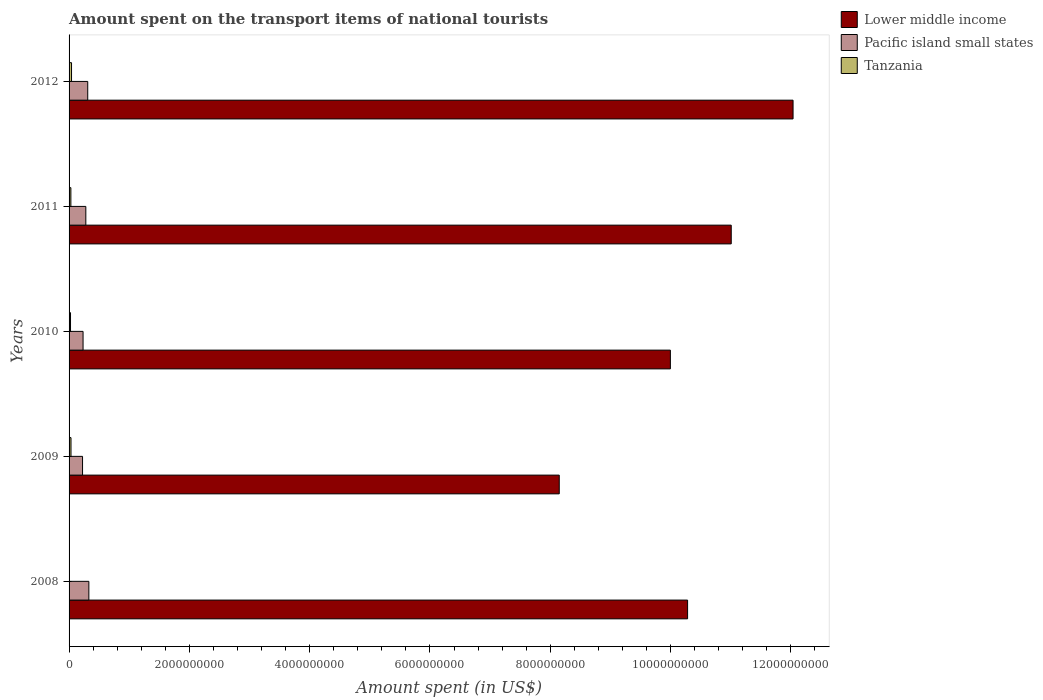How many different coloured bars are there?
Offer a terse response. 3. Are the number of bars per tick equal to the number of legend labels?
Your response must be concise. Yes. Are the number of bars on each tick of the Y-axis equal?
Provide a short and direct response. Yes. What is the amount spent on the transport items of national tourists in Tanzania in 2010?
Ensure brevity in your answer.  2.40e+07. Across all years, what is the maximum amount spent on the transport items of national tourists in Lower middle income?
Offer a very short reply. 1.20e+1. Across all years, what is the minimum amount spent on the transport items of national tourists in Pacific island small states?
Offer a very short reply. 2.24e+08. What is the total amount spent on the transport items of national tourists in Pacific island small states in the graph?
Offer a terse response. 1.37e+09. What is the difference between the amount spent on the transport items of national tourists in Pacific island small states in 2010 and that in 2012?
Provide a short and direct response. -7.77e+07. What is the difference between the amount spent on the transport items of national tourists in Tanzania in 2008 and the amount spent on the transport items of national tourists in Lower middle income in 2012?
Ensure brevity in your answer.  -1.20e+1. What is the average amount spent on the transport items of national tourists in Tanzania per year?
Keep it short and to the point. 2.62e+07. In the year 2012, what is the difference between the amount spent on the transport items of national tourists in Pacific island small states and amount spent on the transport items of national tourists in Lower middle income?
Offer a terse response. -1.17e+1. In how many years, is the amount spent on the transport items of national tourists in Pacific island small states greater than 11200000000 US$?
Your answer should be very brief. 0. What is the ratio of the amount spent on the transport items of national tourists in Tanzania in 2010 to that in 2011?
Provide a succinct answer. 0.8. Is the difference between the amount spent on the transport items of national tourists in Pacific island small states in 2008 and 2012 greater than the difference between the amount spent on the transport items of national tourists in Lower middle income in 2008 and 2012?
Provide a short and direct response. Yes. What is the difference between the highest and the second highest amount spent on the transport items of national tourists in Pacific island small states?
Make the answer very short. 1.85e+07. What is the difference between the highest and the lowest amount spent on the transport items of national tourists in Lower middle income?
Your answer should be very brief. 3.89e+09. Is the sum of the amount spent on the transport items of national tourists in Tanzania in 2010 and 2011 greater than the maximum amount spent on the transport items of national tourists in Lower middle income across all years?
Your answer should be compact. No. What does the 1st bar from the top in 2012 represents?
Offer a terse response. Tanzania. What does the 2nd bar from the bottom in 2011 represents?
Offer a terse response. Pacific island small states. Is it the case that in every year, the sum of the amount spent on the transport items of national tourists in Tanzania and amount spent on the transport items of national tourists in Pacific island small states is greater than the amount spent on the transport items of national tourists in Lower middle income?
Offer a very short reply. No. How many bars are there?
Give a very brief answer. 15. What is the difference between two consecutive major ticks on the X-axis?
Your answer should be compact. 2.00e+09. Are the values on the major ticks of X-axis written in scientific E-notation?
Provide a short and direct response. No. Does the graph contain any zero values?
Make the answer very short. No. What is the title of the graph?
Give a very brief answer. Amount spent on the transport items of national tourists. What is the label or title of the X-axis?
Make the answer very short. Amount spent (in US$). What is the Amount spent (in US$) of Lower middle income in 2008?
Your response must be concise. 1.03e+1. What is the Amount spent (in US$) of Pacific island small states in 2008?
Provide a succinct answer. 3.29e+08. What is the Amount spent (in US$) of Tanzania in 2008?
Your answer should be very brief. 4.00e+06. What is the Amount spent (in US$) in Lower middle income in 2009?
Offer a terse response. 8.15e+09. What is the Amount spent (in US$) of Pacific island small states in 2009?
Offer a very short reply. 2.24e+08. What is the Amount spent (in US$) of Tanzania in 2009?
Offer a terse response. 3.20e+07. What is the Amount spent (in US$) of Lower middle income in 2010?
Keep it short and to the point. 1.00e+1. What is the Amount spent (in US$) in Pacific island small states in 2010?
Your answer should be compact. 2.33e+08. What is the Amount spent (in US$) of Tanzania in 2010?
Make the answer very short. 2.40e+07. What is the Amount spent (in US$) in Lower middle income in 2011?
Your answer should be compact. 1.10e+1. What is the Amount spent (in US$) in Pacific island small states in 2011?
Provide a short and direct response. 2.79e+08. What is the Amount spent (in US$) in Tanzania in 2011?
Offer a very short reply. 3.00e+07. What is the Amount spent (in US$) of Lower middle income in 2012?
Give a very brief answer. 1.20e+1. What is the Amount spent (in US$) in Pacific island small states in 2012?
Give a very brief answer. 3.10e+08. What is the Amount spent (in US$) in Tanzania in 2012?
Provide a short and direct response. 4.10e+07. Across all years, what is the maximum Amount spent (in US$) of Lower middle income?
Offer a very short reply. 1.20e+1. Across all years, what is the maximum Amount spent (in US$) of Pacific island small states?
Your response must be concise. 3.29e+08. Across all years, what is the maximum Amount spent (in US$) of Tanzania?
Give a very brief answer. 4.10e+07. Across all years, what is the minimum Amount spent (in US$) in Lower middle income?
Ensure brevity in your answer.  8.15e+09. Across all years, what is the minimum Amount spent (in US$) in Pacific island small states?
Your response must be concise. 2.24e+08. Across all years, what is the minimum Amount spent (in US$) in Tanzania?
Your response must be concise. 4.00e+06. What is the total Amount spent (in US$) of Lower middle income in the graph?
Your response must be concise. 5.15e+1. What is the total Amount spent (in US$) in Pacific island small states in the graph?
Your answer should be compact. 1.37e+09. What is the total Amount spent (in US$) in Tanzania in the graph?
Ensure brevity in your answer.  1.31e+08. What is the difference between the Amount spent (in US$) in Lower middle income in 2008 and that in 2009?
Your answer should be very brief. 2.13e+09. What is the difference between the Amount spent (in US$) of Pacific island small states in 2008 and that in 2009?
Ensure brevity in your answer.  1.05e+08. What is the difference between the Amount spent (in US$) of Tanzania in 2008 and that in 2009?
Give a very brief answer. -2.80e+07. What is the difference between the Amount spent (in US$) of Lower middle income in 2008 and that in 2010?
Provide a short and direct response. 2.86e+08. What is the difference between the Amount spent (in US$) of Pacific island small states in 2008 and that in 2010?
Provide a succinct answer. 9.62e+07. What is the difference between the Amount spent (in US$) of Tanzania in 2008 and that in 2010?
Ensure brevity in your answer.  -2.00e+07. What is the difference between the Amount spent (in US$) in Lower middle income in 2008 and that in 2011?
Offer a terse response. -7.26e+08. What is the difference between the Amount spent (in US$) in Pacific island small states in 2008 and that in 2011?
Offer a very short reply. 5.02e+07. What is the difference between the Amount spent (in US$) in Tanzania in 2008 and that in 2011?
Your answer should be compact. -2.60e+07. What is the difference between the Amount spent (in US$) of Lower middle income in 2008 and that in 2012?
Your answer should be compact. -1.75e+09. What is the difference between the Amount spent (in US$) of Pacific island small states in 2008 and that in 2012?
Offer a terse response. 1.85e+07. What is the difference between the Amount spent (in US$) of Tanzania in 2008 and that in 2012?
Provide a succinct answer. -3.70e+07. What is the difference between the Amount spent (in US$) of Lower middle income in 2009 and that in 2010?
Your response must be concise. -1.85e+09. What is the difference between the Amount spent (in US$) in Pacific island small states in 2009 and that in 2010?
Provide a succinct answer. -8.73e+06. What is the difference between the Amount spent (in US$) in Lower middle income in 2009 and that in 2011?
Provide a succinct answer. -2.86e+09. What is the difference between the Amount spent (in US$) in Pacific island small states in 2009 and that in 2011?
Ensure brevity in your answer.  -5.47e+07. What is the difference between the Amount spent (in US$) of Tanzania in 2009 and that in 2011?
Make the answer very short. 2.00e+06. What is the difference between the Amount spent (in US$) of Lower middle income in 2009 and that in 2012?
Provide a succinct answer. -3.89e+09. What is the difference between the Amount spent (in US$) of Pacific island small states in 2009 and that in 2012?
Offer a terse response. -8.64e+07. What is the difference between the Amount spent (in US$) in Tanzania in 2009 and that in 2012?
Give a very brief answer. -9.00e+06. What is the difference between the Amount spent (in US$) in Lower middle income in 2010 and that in 2011?
Your answer should be very brief. -1.01e+09. What is the difference between the Amount spent (in US$) in Pacific island small states in 2010 and that in 2011?
Your answer should be very brief. -4.60e+07. What is the difference between the Amount spent (in US$) of Tanzania in 2010 and that in 2011?
Your answer should be very brief. -6.00e+06. What is the difference between the Amount spent (in US$) in Lower middle income in 2010 and that in 2012?
Make the answer very short. -2.04e+09. What is the difference between the Amount spent (in US$) in Pacific island small states in 2010 and that in 2012?
Offer a terse response. -7.77e+07. What is the difference between the Amount spent (in US$) of Tanzania in 2010 and that in 2012?
Ensure brevity in your answer.  -1.70e+07. What is the difference between the Amount spent (in US$) of Lower middle income in 2011 and that in 2012?
Your response must be concise. -1.03e+09. What is the difference between the Amount spent (in US$) in Pacific island small states in 2011 and that in 2012?
Make the answer very short. -3.17e+07. What is the difference between the Amount spent (in US$) in Tanzania in 2011 and that in 2012?
Keep it short and to the point. -1.10e+07. What is the difference between the Amount spent (in US$) of Lower middle income in 2008 and the Amount spent (in US$) of Pacific island small states in 2009?
Keep it short and to the point. 1.01e+1. What is the difference between the Amount spent (in US$) of Lower middle income in 2008 and the Amount spent (in US$) of Tanzania in 2009?
Your answer should be compact. 1.03e+1. What is the difference between the Amount spent (in US$) of Pacific island small states in 2008 and the Amount spent (in US$) of Tanzania in 2009?
Provide a succinct answer. 2.97e+08. What is the difference between the Amount spent (in US$) of Lower middle income in 2008 and the Amount spent (in US$) of Pacific island small states in 2010?
Give a very brief answer. 1.00e+1. What is the difference between the Amount spent (in US$) in Lower middle income in 2008 and the Amount spent (in US$) in Tanzania in 2010?
Offer a terse response. 1.03e+1. What is the difference between the Amount spent (in US$) of Pacific island small states in 2008 and the Amount spent (in US$) of Tanzania in 2010?
Make the answer very short. 3.05e+08. What is the difference between the Amount spent (in US$) of Lower middle income in 2008 and the Amount spent (in US$) of Pacific island small states in 2011?
Make the answer very short. 1.00e+1. What is the difference between the Amount spent (in US$) of Lower middle income in 2008 and the Amount spent (in US$) of Tanzania in 2011?
Keep it short and to the point. 1.03e+1. What is the difference between the Amount spent (in US$) in Pacific island small states in 2008 and the Amount spent (in US$) in Tanzania in 2011?
Offer a very short reply. 2.99e+08. What is the difference between the Amount spent (in US$) in Lower middle income in 2008 and the Amount spent (in US$) in Pacific island small states in 2012?
Your response must be concise. 9.97e+09. What is the difference between the Amount spent (in US$) of Lower middle income in 2008 and the Amount spent (in US$) of Tanzania in 2012?
Provide a short and direct response. 1.02e+1. What is the difference between the Amount spent (in US$) of Pacific island small states in 2008 and the Amount spent (in US$) of Tanzania in 2012?
Give a very brief answer. 2.88e+08. What is the difference between the Amount spent (in US$) of Lower middle income in 2009 and the Amount spent (in US$) of Pacific island small states in 2010?
Keep it short and to the point. 7.92e+09. What is the difference between the Amount spent (in US$) in Lower middle income in 2009 and the Amount spent (in US$) in Tanzania in 2010?
Provide a succinct answer. 8.12e+09. What is the difference between the Amount spent (in US$) in Pacific island small states in 2009 and the Amount spent (in US$) in Tanzania in 2010?
Make the answer very short. 2.00e+08. What is the difference between the Amount spent (in US$) of Lower middle income in 2009 and the Amount spent (in US$) of Pacific island small states in 2011?
Provide a succinct answer. 7.87e+09. What is the difference between the Amount spent (in US$) in Lower middle income in 2009 and the Amount spent (in US$) in Tanzania in 2011?
Keep it short and to the point. 8.12e+09. What is the difference between the Amount spent (in US$) in Pacific island small states in 2009 and the Amount spent (in US$) in Tanzania in 2011?
Offer a very short reply. 1.94e+08. What is the difference between the Amount spent (in US$) in Lower middle income in 2009 and the Amount spent (in US$) in Pacific island small states in 2012?
Make the answer very short. 7.84e+09. What is the difference between the Amount spent (in US$) of Lower middle income in 2009 and the Amount spent (in US$) of Tanzania in 2012?
Offer a terse response. 8.11e+09. What is the difference between the Amount spent (in US$) of Pacific island small states in 2009 and the Amount spent (in US$) of Tanzania in 2012?
Make the answer very short. 1.83e+08. What is the difference between the Amount spent (in US$) in Lower middle income in 2010 and the Amount spent (in US$) in Pacific island small states in 2011?
Ensure brevity in your answer.  9.72e+09. What is the difference between the Amount spent (in US$) in Lower middle income in 2010 and the Amount spent (in US$) in Tanzania in 2011?
Your answer should be compact. 9.97e+09. What is the difference between the Amount spent (in US$) of Pacific island small states in 2010 and the Amount spent (in US$) of Tanzania in 2011?
Your answer should be very brief. 2.03e+08. What is the difference between the Amount spent (in US$) of Lower middle income in 2010 and the Amount spent (in US$) of Pacific island small states in 2012?
Give a very brief answer. 9.69e+09. What is the difference between the Amount spent (in US$) in Lower middle income in 2010 and the Amount spent (in US$) in Tanzania in 2012?
Make the answer very short. 9.96e+09. What is the difference between the Amount spent (in US$) of Pacific island small states in 2010 and the Amount spent (in US$) of Tanzania in 2012?
Offer a terse response. 1.92e+08. What is the difference between the Amount spent (in US$) in Lower middle income in 2011 and the Amount spent (in US$) in Pacific island small states in 2012?
Keep it short and to the point. 1.07e+1. What is the difference between the Amount spent (in US$) of Lower middle income in 2011 and the Amount spent (in US$) of Tanzania in 2012?
Your answer should be compact. 1.10e+1. What is the difference between the Amount spent (in US$) of Pacific island small states in 2011 and the Amount spent (in US$) of Tanzania in 2012?
Your answer should be very brief. 2.38e+08. What is the average Amount spent (in US$) of Lower middle income per year?
Give a very brief answer. 1.03e+1. What is the average Amount spent (in US$) of Pacific island small states per year?
Ensure brevity in your answer.  2.75e+08. What is the average Amount spent (in US$) of Tanzania per year?
Offer a very short reply. 2.62e+07. In the year 2008, what is the difference between the Amount spent (in US$) of Lower middle income and Amount spent (in US$) of Pacific island small states?
Your answer should be compact. 9.95e+09. In the year 2008, what is the difference between the Amount spent (in US$) of Lower middle income and Amount spent (in US$) of Tanzania?
Offer a very short reply. 1.03e+1. In the year 2008, what is the difference between the Amount spent (in US$) in Pacific island small states and Amount spent (in US$) in Tanzania?
Your response must be concise. 3.25e+08. In the year 2009, what is the difference between the Amount spent (in US$) in Lower middle income and Amount spent (in US$) in Pacific island small states?
Offer a terse response. 7.92e+09. In the year 2009, what is the difference between the Amount spent (in US$) of Lower middle income and Amount spent (in US$) of Tanzania?
Your answer should be very brief. 8.12e+09. In the year 2009, what is the difference between the Amount spent (in US$) in Pacific island small states and Amount spent (in US$) in Tanzania?
Keep it short and to the point. 1.92e+08. In the year 2010, what is the difference between the Amount spent (in US$) of Lower middle income and Amount spent (in US$) of Pacific island small states?
Your answer should be compact. 9.76e+09. In the year 2010, what is the difference between the Amount spent (in US$) in Lower middle income and Amount spent (in US$) in Tanzania?
Make the answer very short. 9.97e+09. In the year 2010, what is the difference between the Amount spent (in US$) of Pacific island small states and Amount spent (in US$) of Tanzania?
Provide a succinct answer. 2.09e+08. In the year 2011, what is the difference between the Amount spent (in US$) of Lower middle income and Amount spent (in US$) of Pacific island small states?
Provide a short and direct response. 1.07e+1. In the year 2011, what is the difference between the Amount spent (in US$) in Lower middle income and Amount spent (in US$) in Tanzania?
Your answer should be compact. 1.10e+1. In the year 2011, what is the difference between the Amount spent (in US$) in Pacific island small states and Amount spent (in US$) in Tanzania?
Your answer should be compact. 2.49e+08. In the year 2012, what is the difference between the Amount spent (in US$) of Lower middle income and Amount spent (in US$) of Pacific island small states?
Give a very brief answer. 1.17e+1. In the year 2012, what is the difference between the Amount spent (in US$) of Lower middle income and Amount spent (in US$) of Tanzania?
Ensure brevity in your answer.  1.20e+1. In the year 2012, what is the difference between the Amount spent (in US$) in Pacific island small states and Amount spent (in US$) in Tanzania?
Offer a very short reply. 2.69e+08. What is the ratio of the Amount spent (in US$) in Lower middle income in 2008 to that in 2009?
Make the answer very short. 1.26. What is the ratio of the Amount spent (in US$) of Pacific island small states in 2008 to that in 2009?
Keep it short and to the point. 1.47. What is the ratio of the Amount spent (in US$) of Tanzania in 2008 to that in 2009?
Your response must be concise. 0.12. What is the ratio of the Amount spent (in US$) of Lower middle income in 2008 to that in 2010?
Ensure brevity in your answer.  1.03. What is the ratio of the Amount spent (in US$) of Pacific island small states in 2008 to that in 2010?
Your answer should be very brief. 1.41. What is the ratio of the Amount spent (in US$) of Tanzania in 2008 to that in 2010?
Provide a short and direct response. 0.17. What is the ratio of the Amount spent (in US$) of Lower middle income in 2008 to that in 2011?
Make the answer very short. 0.93. What is the ratio of the Amount spent (in US$) in Pacific island small states in 2008 to that in 2011?
Make the answer very short. 1.18. What is the ratio of the Amount spent (in US$) of Tanzania in 2008 to that in 2011?
Ensure brevity in your answer.  0.13. What is the ratio of the Amount spent (in US$) in Lower middle income in 2008 to that in 2012?
Give a very brief answer. 0.85. What is the ratio of the Amount spent (in US$) in Pacific island small states in 2008 to that in 2012?
Your answer should be very brief. 1.06. What is the ratio of the Amount spent (in US$) in Tanzania in 2008 to that in 2012?
Your response must be concise. 0.1. What is the ratio of the Amount spent (in US$) in Lower middle income in 2009 to that in 2010?
Your answer should be very brief. 0.82. What is the ratio of the Amount spent (in US$) in Pacific island small states in 2009 to that in 2010?
Offer a very short reply. 0.96. What is the ratio of the Amount spent (in US$) in Lower middle income in 2009 to that in 2011?
Provide a short and direct response. 0.74. What is the ratio of the Amount spent (in US$) of Pacific island small states in 2009 to that in 2011?
Keep it short and to the point. 0.8. What is the ratio of the Amount spent (in US$) in Tanzania in 2009 to that in 2011?
Your answer should be very brief. 1.07. What is the ratio of the Amount spent (in US$) of Lower middle income in 2009 to that in 2012?
Your response must be concise. 0.68. What is the ratio of the Amount spent (in US$) of Pacific island small states in 2009 to that in 2012?
Offer a terse response. 0.72. What is the ratio of the Amount spent (in US$) in Tanzania in 2009 to that in 2012?
Your answer should be compact. 0.78. What is the ratio of the Amount spent (in US$) of Lower middle income in 2010 to that in 2011?
Offer a terse response. 0.91. What is the ratio of the Amount spent (in US$) of Pacific island small states in 2010 to that in 2011?
Your response must be concise. 0.83. What is the ratio of the Amount spent (in US$) of Lower middle income in 2010 to that in 2012?
Give a very brief answer. 0.83. What is the ratio of the Amount spent (in US$) in Pacific island small states in 2010 to that in 2012?
Keep it short and to the point. 0.75. What is the ratio of the Amount spent (in US$) in Tanzania in 2010 to that in 2012?
Offer a very short reply. 0.59. What is the ratio of the Amount spent (in US$) of Lower middle income in 2011 to that in 2012?
Offer a terse response. 0.91. What is the ratio of the Amount spent (in US$) of Pacific island small states in 2011 to that in 2012?
Your response must be concise. 0.9. What is the ratio of the Amount spent (in US$) in Tanzania in 2011 to that in 2012?
Provide a short and direct response. 0.73. What is the difference between the highest and the second highest Amount spent (in US$) of Lower middle income?
Provide a short and direct response. 1.03e+09. What is the difference between the highest and the second highest Amount spent (in US$) in Pacific island small states?
Provide a succinct answer. 1.85e+07. What is the difference between the highest and the second highest Amount spent (in US$) of Tanzania?
Provide a succinct answer. 9.00e+06. What is the difference between the highest and the lowest Amount spent (in US$) in Lower middle income?
Provide a succinct answer. 3.89e+09. What is the difference between the highest and the lowest Amount spent (in US$) of Pacific island small states?
Offer a very short reply. 1.05e+08. What is the difference between the highest and the lowest Amount spent (in US$) of Tanzania?
Your answer should be very brief. 3.70e+07. 